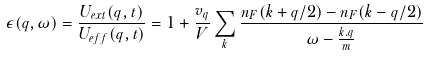Convert formula to latex. <formula><loc_0><loc_0><loc_500><loc_500>\epsilon ( q , \omega ) = \frac { U _ { e x t } ( q , t ) } { U _ { e f f } ( q , t ) } = 1 + \frac { v _ { q } } { V } \sum _ { k } \frac { n _ { F } ( k + q / 2 ) - n _ { F } ( k - q / 2 ) } { \omega - \frac { k . q } { m } }</formula> 